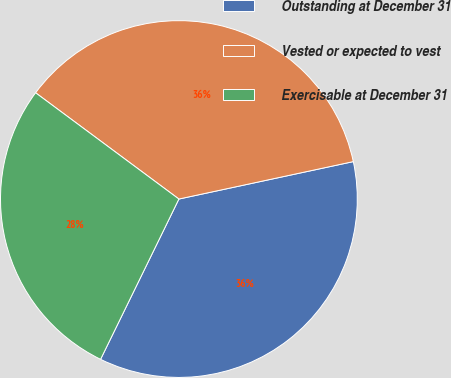Convert chart. <chart><loc_0><loc_0><loc_500><loc_500><pie_chart><fcel>Outstanding at December 31<fcel>Vested or expected to vest<fcel>Exercisable at December 31<nl><fcel>35.6%<fcel>36.48%<fcel>27.92%<nl></chart> 